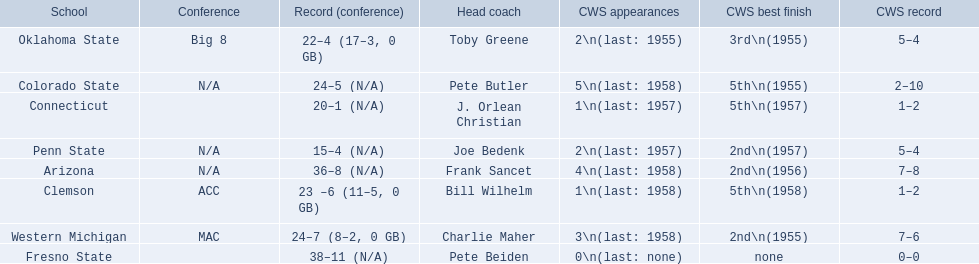Could you parse the entire table as a dict? {'header': ['School', 'Conference', 'Record (conference)', 'Head coach', 'CWS appearances', 'CWS best finish', 'CWS record'], 'rows': [['Oklahoma State', 'Big 8', '22–4 (17–3, 0 GB)', 'Toby Greene', '2\\n(last: 1955)', '3rd\\n(1955)', '5–4'], ['Colorado State', 'N/A', '24–5 (N/A)', 'Pete Butler', '5\\n(last: 1958)', '5th\\n(1955)', '2–10'], ['Connecticut', '', '20–1 (N/A)', 'J. Orlean Christian', '1\\n(last: 1957)', '5th\\n(1957)', '1–2'], ['Penn State', 'N/A', '15–4 (N/A)', 'Joe Bedenk', '2\\n(last: 1957)', '2nd\\n(1957)', '5–4'], ['Arizona', 'N/A', '36–8 (N/A)', 'Frank Sancet', '4\\n(last: 1958)', '2nd\\n(1956)', '7–8'], ['Clemson', 'ACC', '23 –6 (11–5, 0 GB)', 'Bill Wilhelm', '1\\n(last: 1958)', '5th\\n(1958)', '1–2'], ['Western Michigan', 'MAC', '24–7 (8–2, 0 GB)', 'Charlie Maher', '3\\n(last: 1958)', '2nd\\n(1955)', '7–6'], ['Fresno State', '', '38–11 (N/A)', 'Pete Beiden', '0\\n(last: none)', 'none', '0–0']]} What are all the schools? Arizona, Clemson, Colorado State, Connecticut, Fresno State, Oklahoma State, Penn State, Western Michigan. Which are clemson and western michigan? Clemson, Western Michigan. Of these, which has more cws appearances? Western Michigan. 